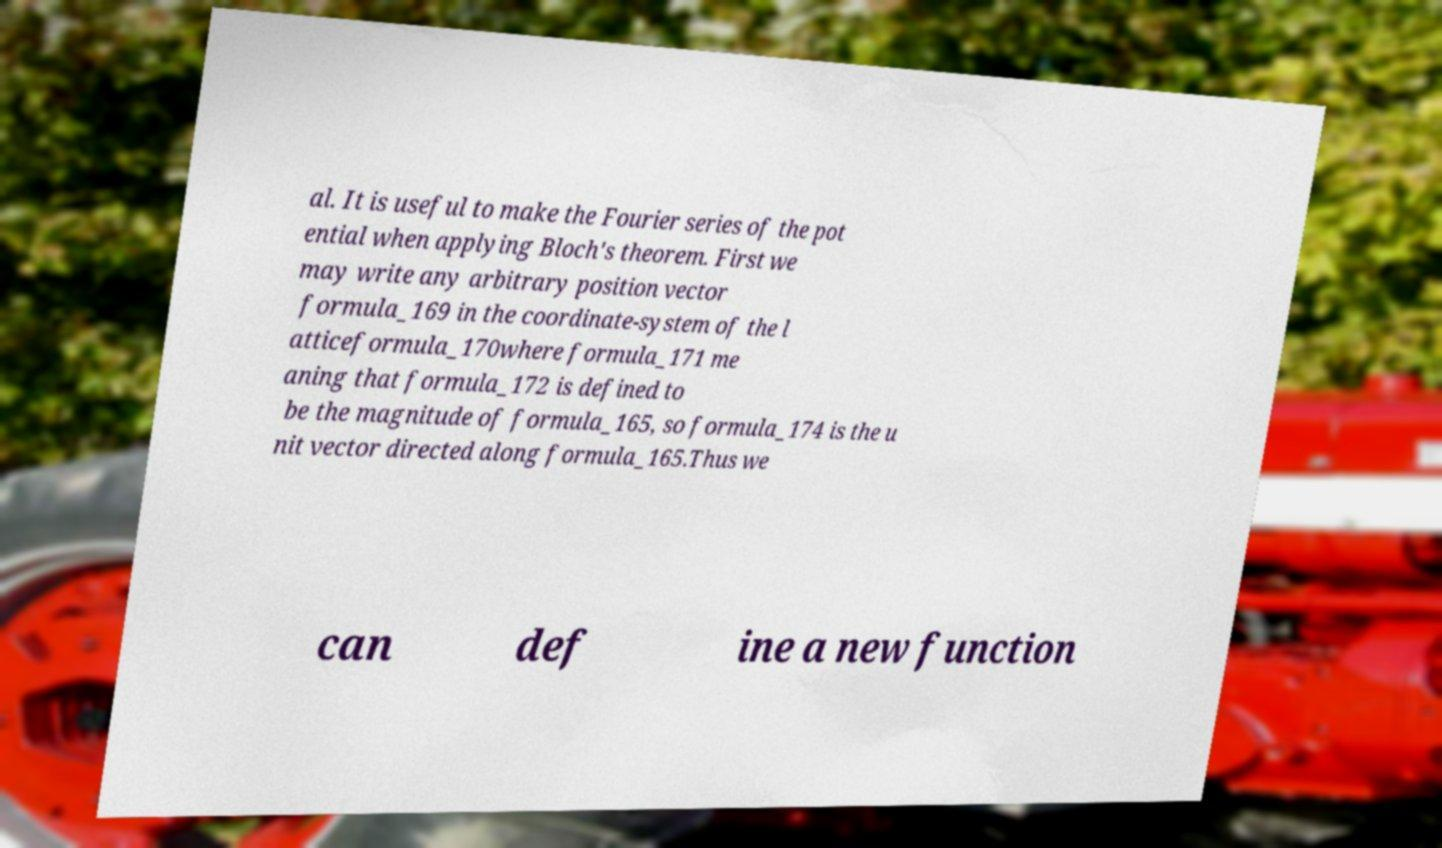Please identify and transcribe the text found in this image. al. It is useful to make the Fourier series of the pot ential when applying Bloch's theorem. First we may write any arbitrary position vector formula_169 in the coordinate-system of the l atticeformula_170where formula_171 me aning that formula_172 is defined to be the magnitude of formula_165, so formula_174 is the u nit vector directed along formula_165.Thus we can def ine a new function 